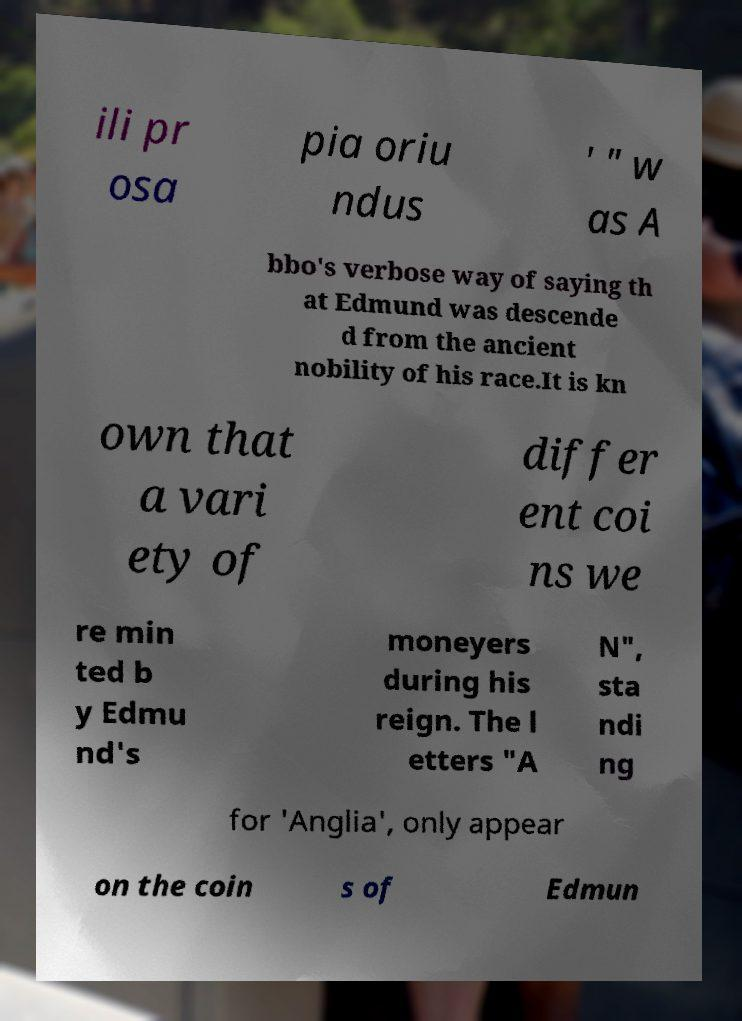What messages or text are displayed in this image? I need them in a readable, typed format. ili pr osa pia oriu ndus ' " w as A bbo's verbose way of saying th at Edmund was descende d from the ancient nobility of his race.It is kn own that a vari ety of differ ent coi ns we re min ted b y Edmu nd's moneyers during his reign. The l etters "A N", sta ndi ng for 'Anglia', only appear on the coin s of Edmun 